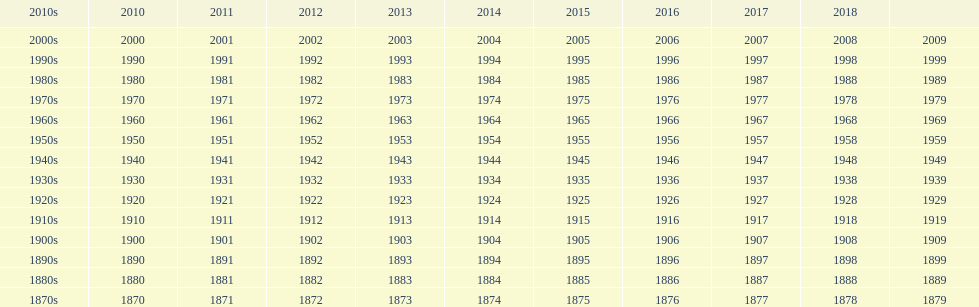Give me the full table as a dictionary. {'header': ['2010s', '2010', '2011', '2012', '2013', '2014', '2015', '2016', '2017', '2018', ''], 'rows': [['2000s', '2000', '2001', '2002', '2003', '2004', '2005', '2006', '2007', '2008', '2009'], ['1990s', '1990', '1991', '1992', '1993', '1994', '1995', '1996', '1997', '1998', '1999'], ['1980s', '1980', '1981', '1982', '1983', '1984', '1985', '1986', '1987', '1988', '1989'], ['1970s', '1970', '1971', '1972', '1973', '1974', '1975', '1976', '1977', '1978', '1979'], ['1960s', '1960', '1961', '1962', '1963', '1964', '1965', '1966', '1967', '1968', '1969'], ['1950s', '1950', '1951', '1952', '1953', '1954', '1955', '1956', '1957', '1958', '1959'], ['1940s', '1940', '1941', '1942', '1943', '1944', '1945', '1946', '1947', '1948', '1949'], ['1930s', '1930', '1931', '1932', '1933', '1934', '1935', '1936', '1937', '1938', '1939'], ['1920s', '1920', '1921', '1922', '1923', '1924', '1925', '1926', '1927', '1928', '1929'], ['1910s', '1910', '1911', '1912', '1913', '1914', '1915', '1916', '1917', '1918', '1919'], ['1900s', '1900', '1901', '1902', '1903', '1904', '1905', '1906', '1907', '1908', '1909'], ['1890s', '1890', '1891', '1892', '1893', '1894', '1895', '1896', '1897', '1898', '1899'], ['1880s', '1880', '1881', '1882', '1883', '1884', '1885', '1886', '1887', '1888', '1889'], ['1870s', '1870', '1871', '1872', '1873', '1874', '1875', '1876', '1877', '1878', '1879']]} What is the earliest year that a film was released? 1870. 